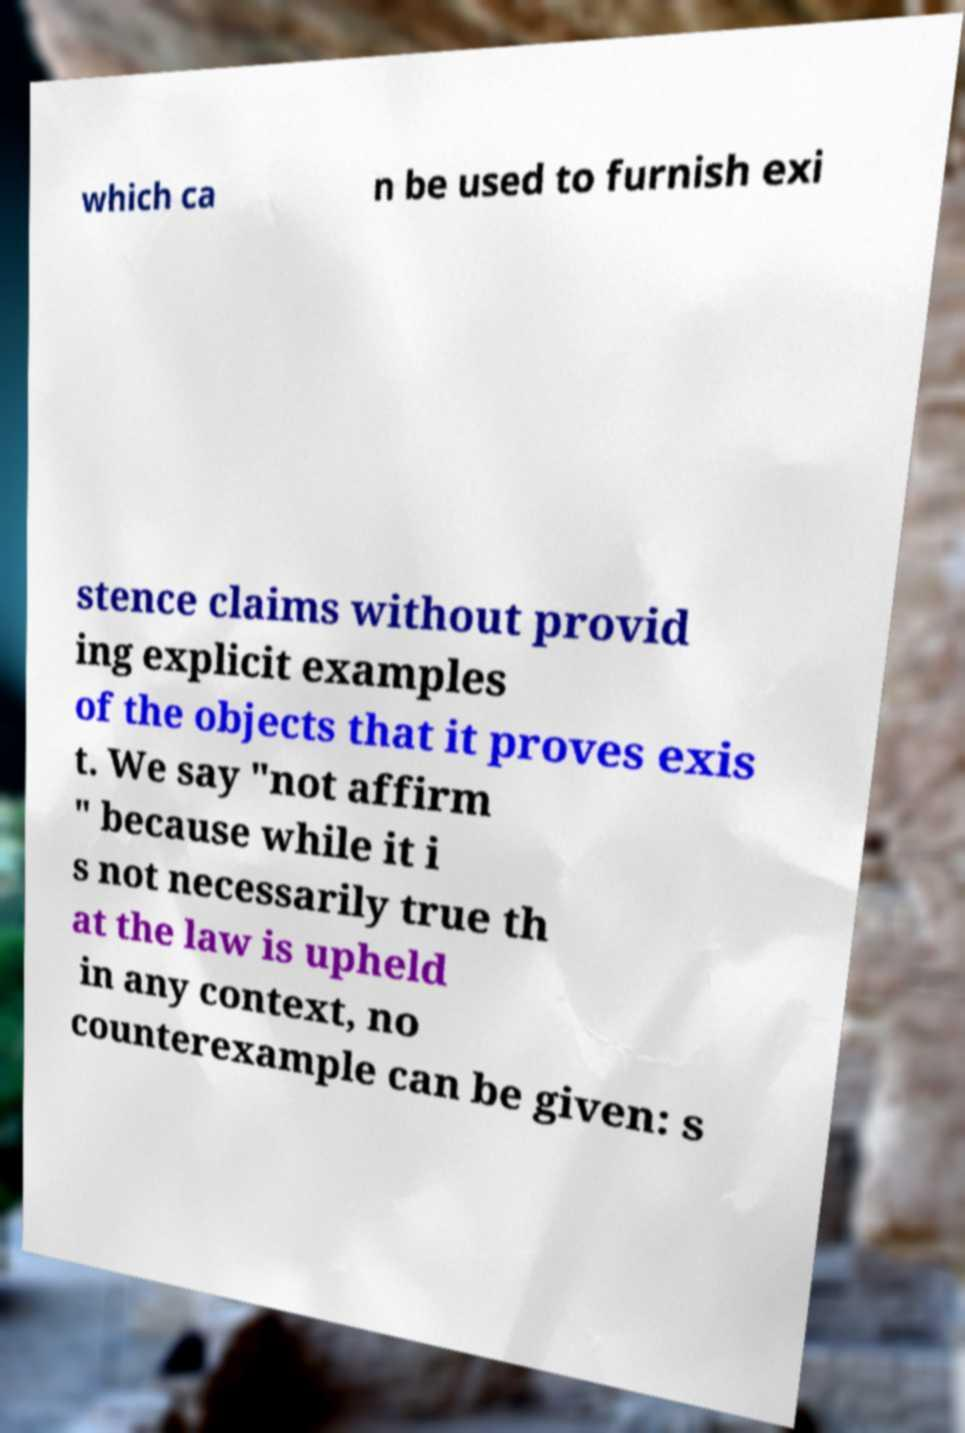What messages or text are displayed in this image? I need them in a readable, typed format. which ca n be used to furnish exi stence claims without provid ing explicit examples of the objects that it proves exis t. We say "not affirm " because while it i s not necessarily true th at the law is upheld in any context, no counterexample can be given: s 